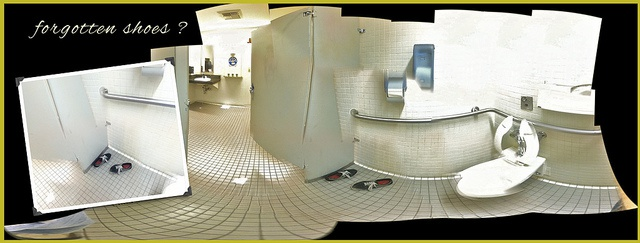Describe the objects in this image and their specific colors. I can see toilet in gold, white, gray, and darkgray tones, sink in gold, white, darkgray, gray, and lightgray tones, and sink in gold, white, darkgray, and gray tones in this image. 